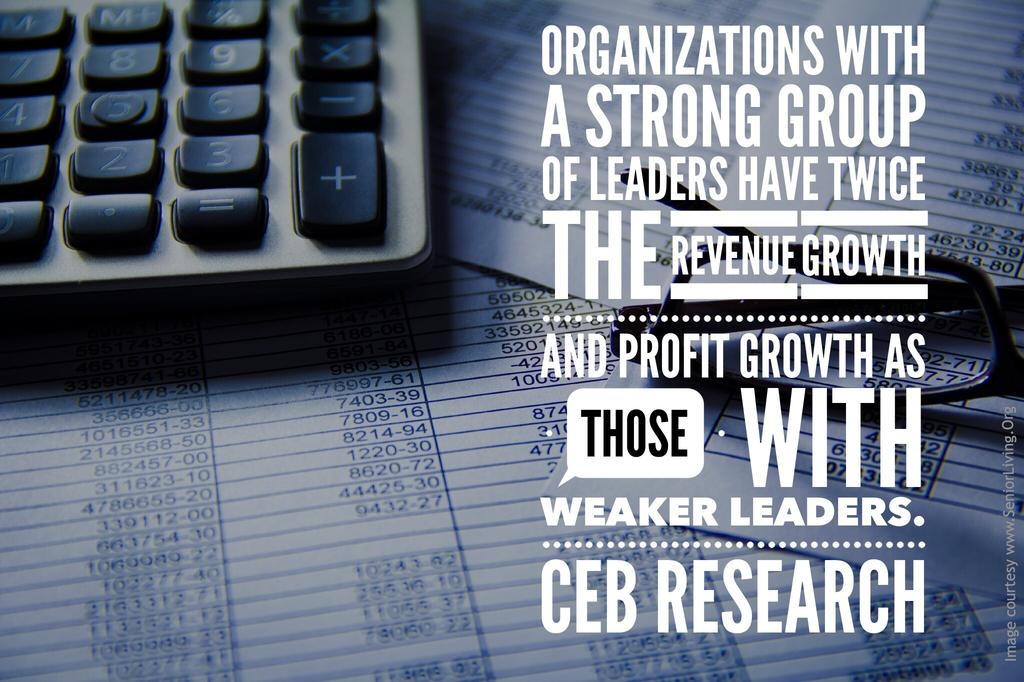<image>
Share a concise interpretation of the image provided. A keyboard on the left with a quote that the last line says CEB Research. 